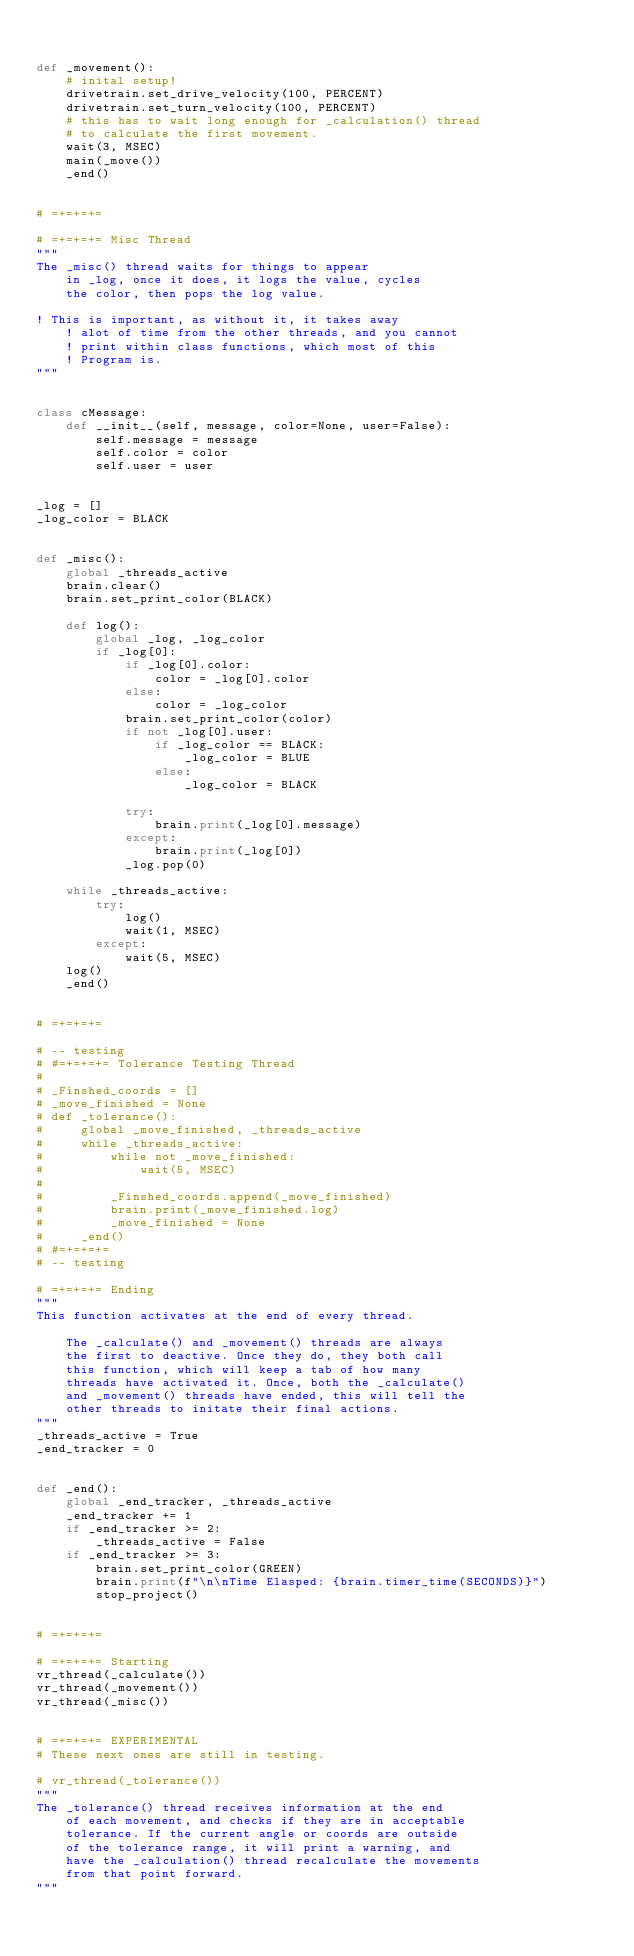<code> <loc_0><loc_0><loc_500><loc_500><_Python_>

def _movement():
    # inital setup!
    drivetrain.set_drive_velocity(100, PERCENT)
    drivetrain.set_turn_velocity(100, PERCENT)
    # this has to wait long enough for _calculation() thread
    # to calculate the first movement.
    wait(3, MSEC)
    main(_move())
    _end()


# =+=+=+=

# =+=+=+= Misc Thread
"""
The _misc() thread waits for things to appear
    in _log, once it does, it logs the value, cycles
    the color, then pops the log value.

! This is important, as without it, it takes away
    ! alot of time from the other threads, and you cannot
    ! print within class functions, which most of this
    ! Program is.
"""


class cMessage:
    def __init__(self, message, color=None, user=False):
        self.message = message
        self.color = color
        self.user = user


_log = []
_log_color = BLACK


def _misc():
    global _threads_active
    brain.clear()
    brain.set_print_color(BLACK)

    def log():
        global _log, _log_color
        if _log[0]:
            if _log[0].color:
                color = _log[0].color
            else:
                color = _log_color
            brain.set_print_color(color)
            if not _log[0].user:
                if _log_color == BLACK:
                    _log_color = BLUE
                else:
                    _log_color = BLACK

            try:
                brain.print(_log[0].message)
            except:
                brain.print(_log[0])
            _log.pop(0)

    while _threads_active:
        try:
            log()
            wait(1, MSEC)
        except:
            wait(5, MSEC)
    log()
    _end()


# =+=+=+=

# -- testing
# #=+=+=+= Tolerance Testing Thread
#
# _Finshed_coords = []
# _move_finished = None
# def _tolerance():
#     global _move_finished, _threads_active
#     while _threads_active:
#         while not _move_finished:
#             wait(5, MSEC)
#
#         _Finshed_coords.append(_move_finished)
#         brain.print(_move_finished.log)
#         _move_finished = None
#     _end()
# #=+=+=+=
# -- testing

# =+=+=+= Ending
"""
This function activates at the end of every thread.

    The _calculate() and _movement() threads are always
    the first to deactive. Once they do, they both call
    this function, which will keep a tab of how many
    threads have activated it. Once, both the _calculate()
    and _movement() threads have ended, this will tell the
    other threads to initate their final actions.
"""
_threads_active = True
_end_tracker = 0


def _end():
    global _end_tracker, _threads_active
    _end_tracker += 1
    if _end_tracker >= 2:
        _threads_active = False
    if _end_tracker >= 3:
        brain.set_print_color(GREEN)
        brain.print(f"\n\nTime Elasped: {brain.timer_time(SECONDS)}")
        stop_project()


# =+=+=+=

# =+=+=+= Starting
vr_thread(_calculate())
vr_thread(_movement())
vr_thread(_misc())


# =+=+=+= EXPERIMENTAL
# These next ones are still in testing.

# vr_thread(_tolerance())
"""
The _tolerance() thread receives information at the end
    of each movement, and checks if they are in acceptable
    tolerance. If the current angle or coords are outside
    of the tolerance range, it will print a warning, and
    have the _calculation() thread recalculate the movements
    from that point forward.
"""</code> 